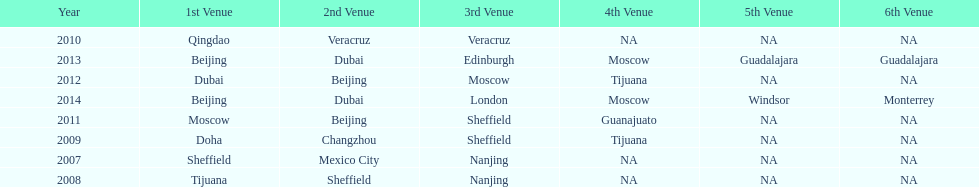In list of venues, how many years was beijing above moscow (1st venue is above 2nd venue, etc)? 3. 